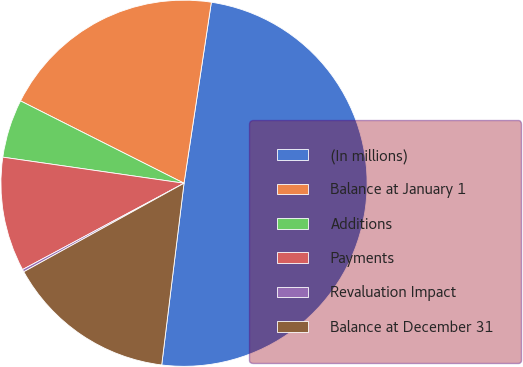Convert chart to OTSL. <chart><loc_0><loc_0><loc_500><loc_500><pie_chart><fcel>(In millions)<fcel>Balance at January 1<fcel>Additions<fcel>Payments<fcel>Revaluation Impact<fcel>Balance at December 31<nl><fcel>49.56%<fcel>19.96%<fcel>5.15%<fcel>10.09%<fcel>0.22%<fcel>15.02%<nl></chart> 